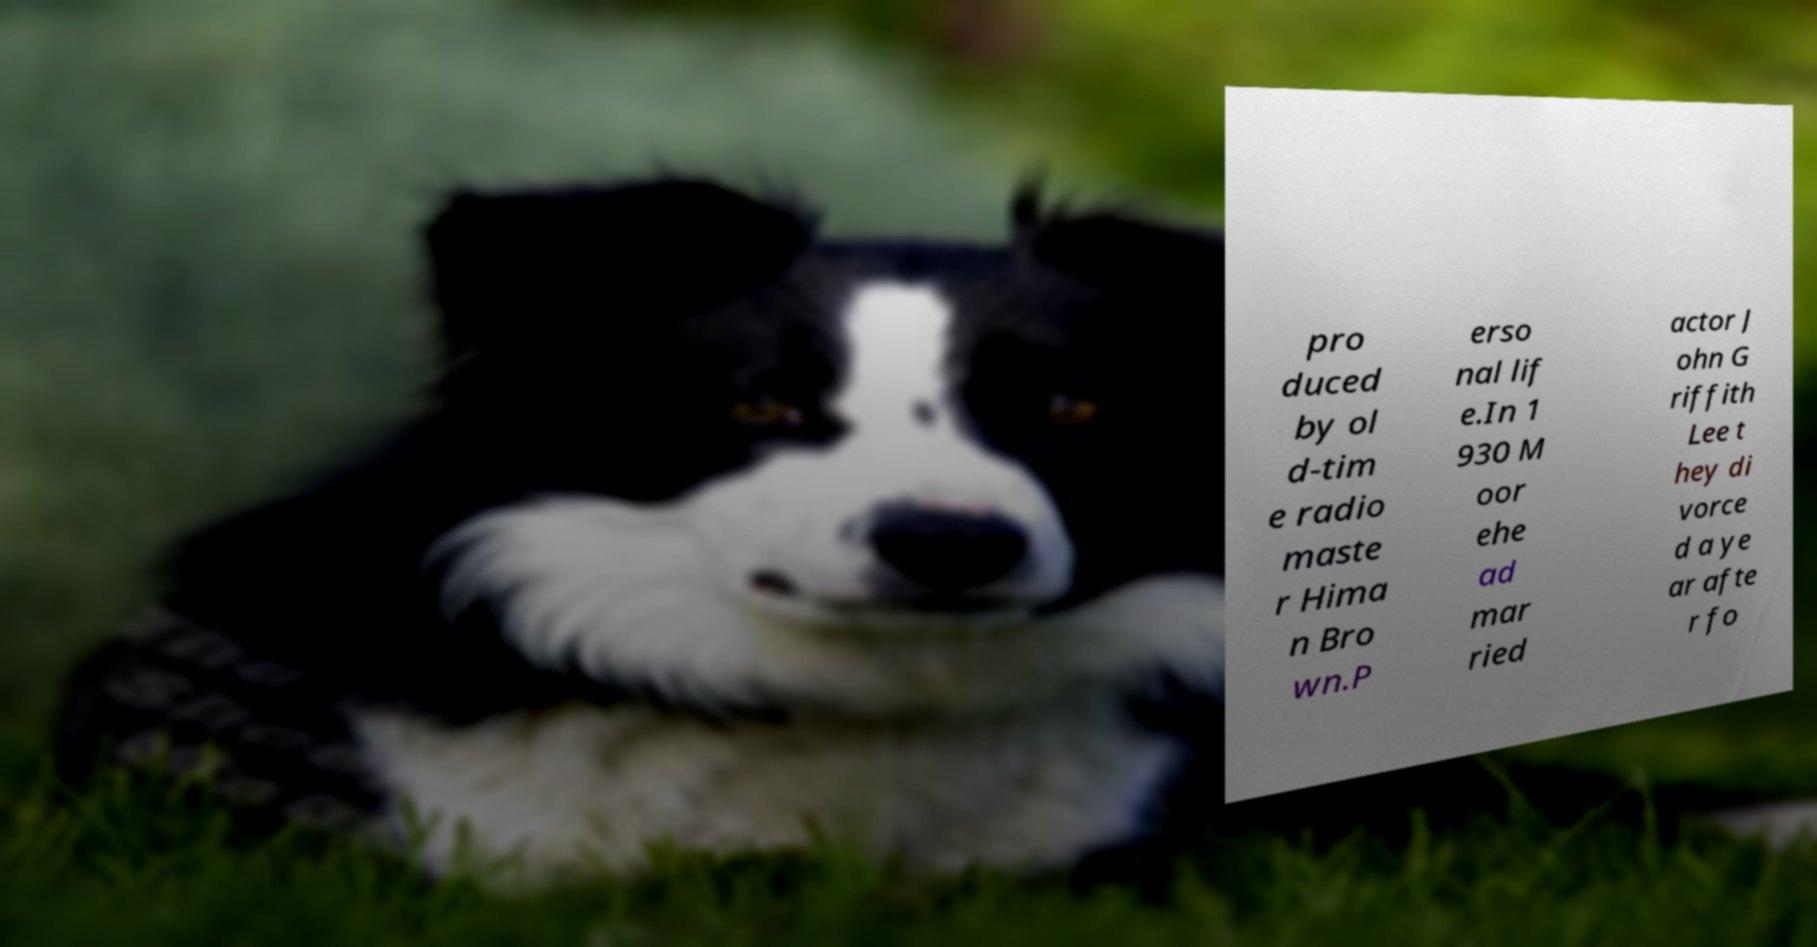For documentation purposes, I need the text within this image transcribed. Could you provide that? pro duced by ol d-tim e radio maste r Hima n Bro wn.P erso nal lif e.In 1 930 M oor ehe ad mar ried actor J ohn G riffith Lee t hey di vorce d a ye ar afte r fo 